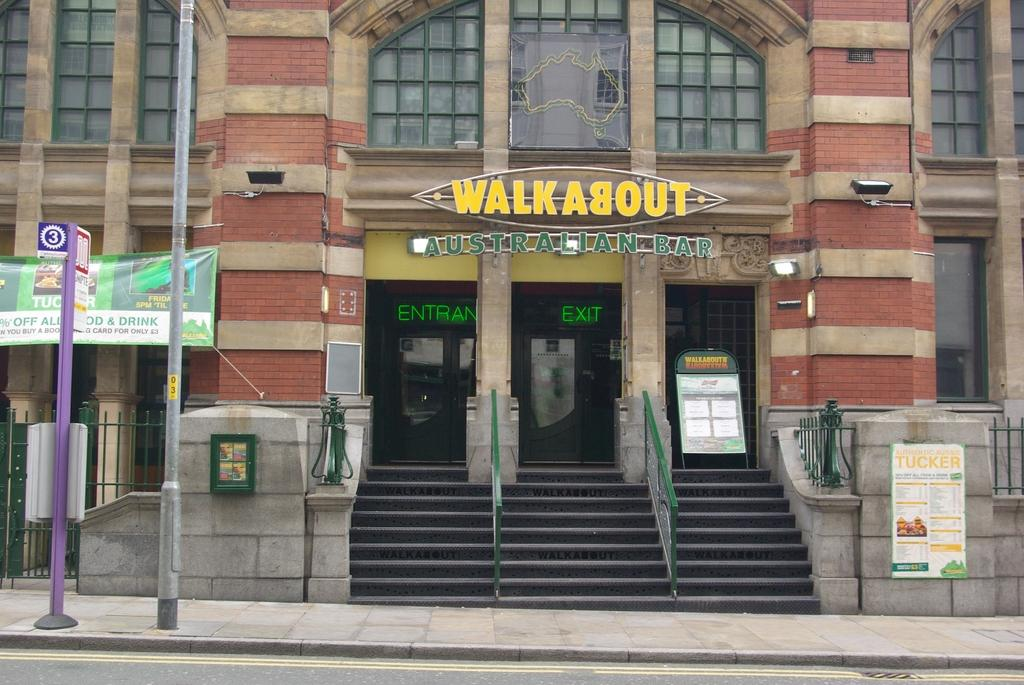What type of structure can be seen in the image? There is a building in the image. What is the primary pathway visible in the image? There is a road in the image. What are the vertical supports in the image used for? There are poles in the image, which may be used for various purposes such as lighting or signage. What are the flat, rectangular objects in the image? There are boards in the image, which could be used for signage or advertising. How can someone access the upper levels of the building in the image? There are stairs in the image, which provide access to different levels of the building. What type of barrier is present in the image? There is fencing in the image, which may be used for security or to demarcate boundaries. What type of canvas is being used to create a painting in the image? There is no canvas or painting present in the image. Is there a camp visible in the image? There is no camp visible in the image. 